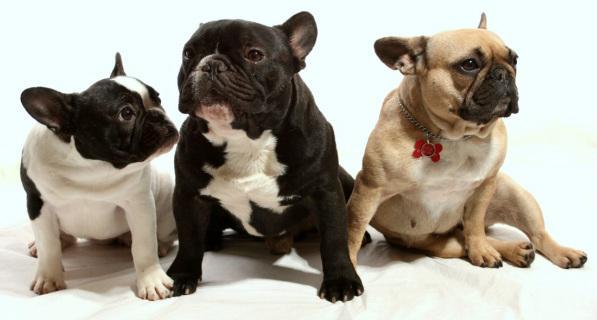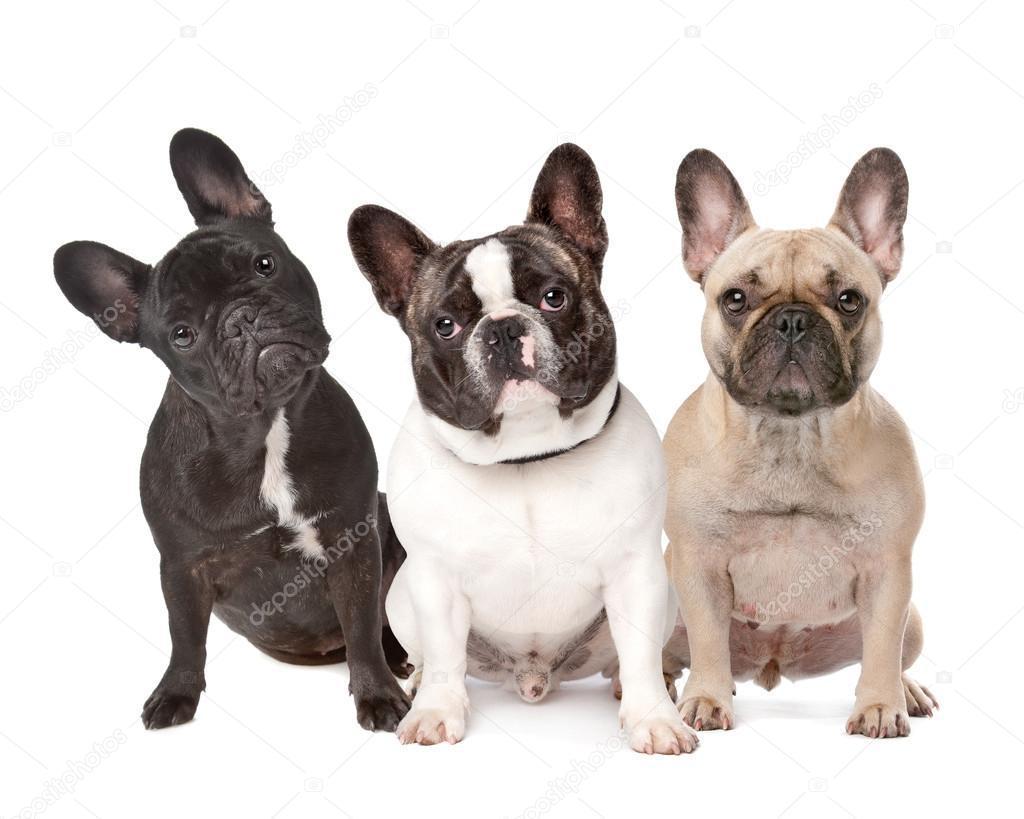The first image is the image on the left, the second image is the image on the right. Given the left and right images, does the statement "There are at least three dogs." hold true? Answer yes or no. Yes. The first image is the image on the left, the second image is the image on the right. Examine the images to the left and right. Is the description "One image contains a single light-colored dog, and the other includes a black dog standing on all fours." accurate? Answer yes or no. No. 